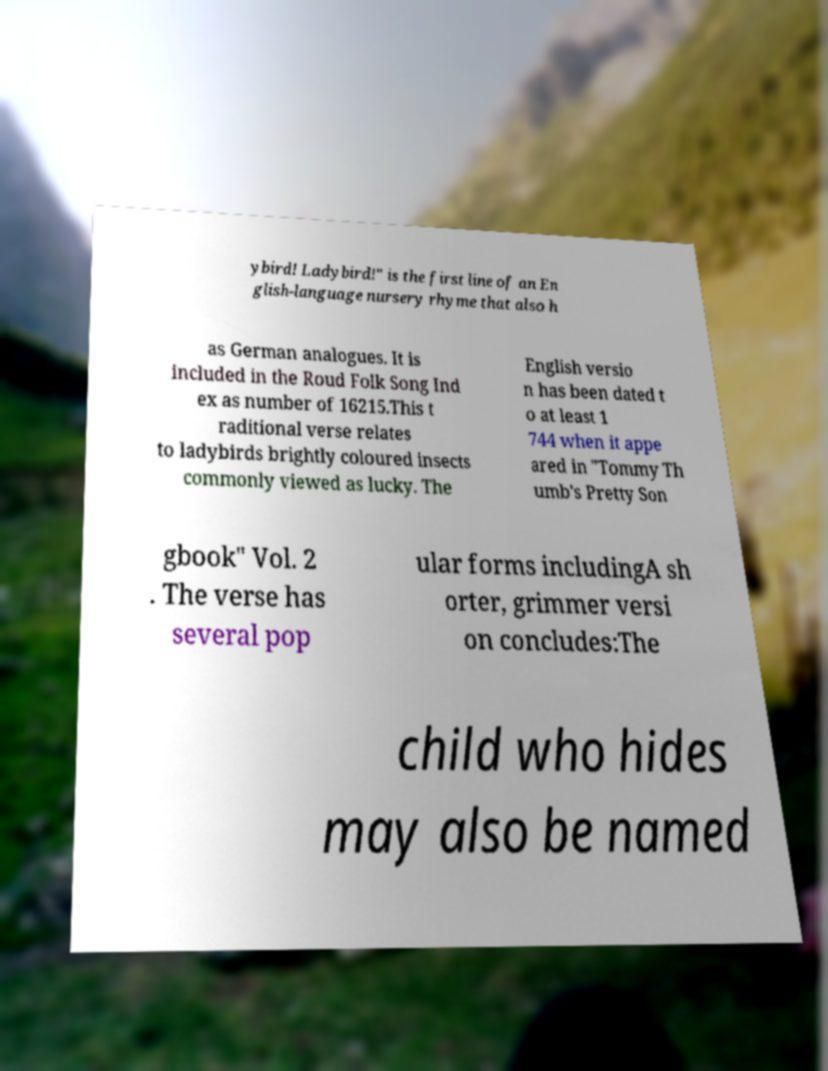Please identify and transcribe the text found in this image. ybird! Ladybird!" is the first line of an En glish-language nursery rhyme that also h as German analogues. It is included in the Roud Folk Song Ind ex as number of 16215.This t raditional verse relates to ladybirds brightly coloured insects commonly viewed as lucky. The English versio n has been dated t o at least 1 744 when it appe ared in "Tommy Th umb's Pretty Son gbook" Vol. 2 . The verse has several pop ular forms includingA sh orter, grimmer versi on concludes:The child who hides may also be named 